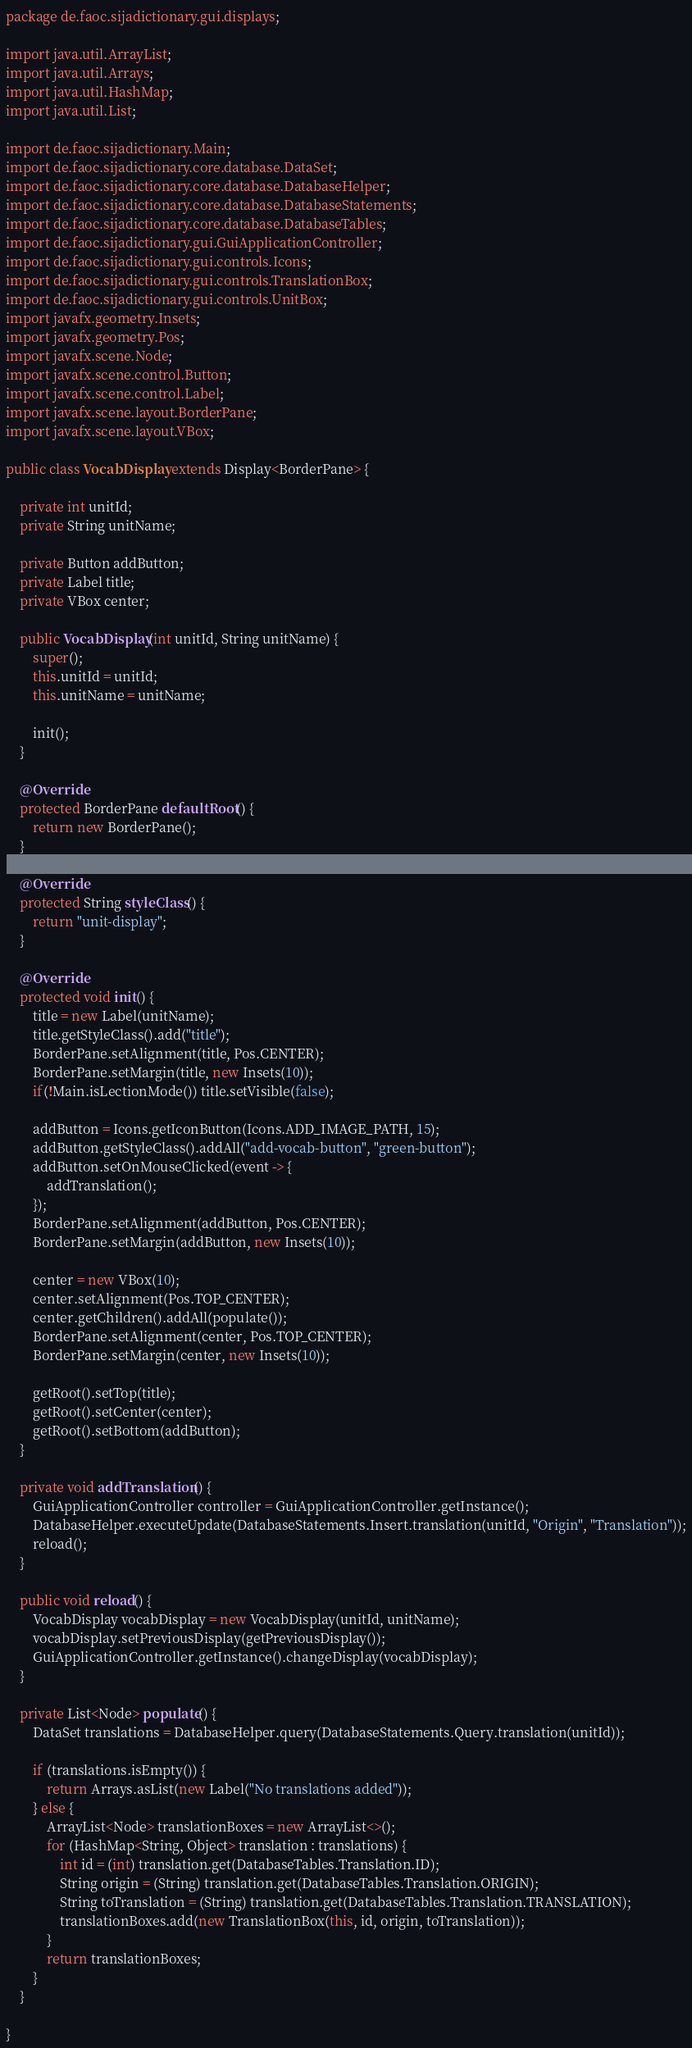Convert code to text. <code><loc_0><loc_0><loc_500><loc_500><_Java_>package de.faoc.sijadictionary.gui.displays;

import java.util.ArrayList;
import java.util.Arrays;
import java.util.HashMap;
import java.util.List;

import de.faoc.sijadictionary.Main;
import de.faoc.sijadictionary.core.database.DataSet;
import de.faoc.sijadictionary.core.database.DatabaseHelper;
import de.faoc.sijadictionary.core.database.DatabaseStatements;
import de.faoc.sijadictionary.core.database.DatabaseTables;
import de.faoc.sijadictionary.gui.GuiApplicationController;
import de.faoc.sijadictionary.gui.controls.Icons;
import de.faoc.sijadictionary.gui.controls.TranslationBox;
import de.faoc.sijadictionary.gui.controls.UnitBox;
import javafx.geometry.Insets;
import javafx.geometry.Pos;
import javafx.scene.Node;
import javafx.scene.control.Button;
import javafx.scene.control.Label;
import javafx.scene.layout.BorderPane;
import javafx.scene.layout.VBox;

public class VocabDisplay extends Display<BorderPane> {

	private int unitId;
	private String unitName;

	private Button addButton;
	private Label title;
	private VBox center;

	public VocabDisplay(int unitId, String unitName) {
		super();
		this.unitId = unitId;
		this.unitName = unitName;
		
		init();
	}

	@Override
	protected BorderPane defaultRoot() {
		return new BorderPane();
	}

	@Override
	protected String styleClass() {
		return "unit-display";
	}

	@Override
	protected void init() {
		title = new Label(unitName);
		title.getStyleClass().add("title");
		BorderPane.setAlignment(title, Pos.CENTER);
		BorderPane.setMargin(title, new Insets(10));
		if(!Main.isLectionMode()) title.setVisible(false);

		addButton = Icons.getIconButton(Icons.ADD_IMAGE_PATH, 15);
		addButton.getStyleClass().addAll("add-vocab-button", "green-button");
		addButton.setOnMouseClicked(event -> {
			addTranslation();
		});
		BorderPane.setAlignment(addButton, Pos.CENTER);
		BorderPane.setMargin(addButton, new Insets(10));

		center = new VBox(10);
		center.setAlignment(Pos.TOP_CENTER);
		center.getChildren().addAll(populate());
		BorderPane.setAlignment(center, Pos.TOP_CENTER);
		BorderPane.setMargin(center, new Insets(10));

		getRoot().setTop(title);
		getRoot().setCenter(center);
		getRoot().setBottom(addButton);
	}

	private void addTranslation() {
		GuiApplicationController controller = GuiApplicationController.getInstance();
		DatabaseHelper.executeUpdate(DatabaseStatements.Insert.translation(unitId, "Origin", "Translation"));
		reload();
	}

	public void reload() {
		VocabDisplay vocabDisplay = new VocabDisplay(unitId, unitName);
		vocabDisplay.setPreviousDisplay(getPreviousDisplay());
		GuiApplicationController.getInstance().changeDisplay(vocabDisplay);
	}

	private List<Node> populate() {
		DataSet translations = DatabaseHelper.query(DatabaseStatements.Query.translation(unitId));
				
		if (translations.isEmpty()) {
			return Arrays.asList(new Label("No translations added"));
		} else {
			ArrayList<Node> translationBoxes = new ArrayList<>();
			for (HashMap<String, Object> translation : translations) {
				int id = (int) translation.get(DatabaseTables.Translation.ID);
				String origin = (String) translation.get(DatabaseTables.Translation.ORIGIN);
				String toTranslation = (String) translation.get(DatabaseTables.Translation.TRANSLATION);
				translationBoxes.add(new TranslationBox(this, id, origin, toTranslation));
			}
			return translationBoxes;
		}
	}

}
</code> 